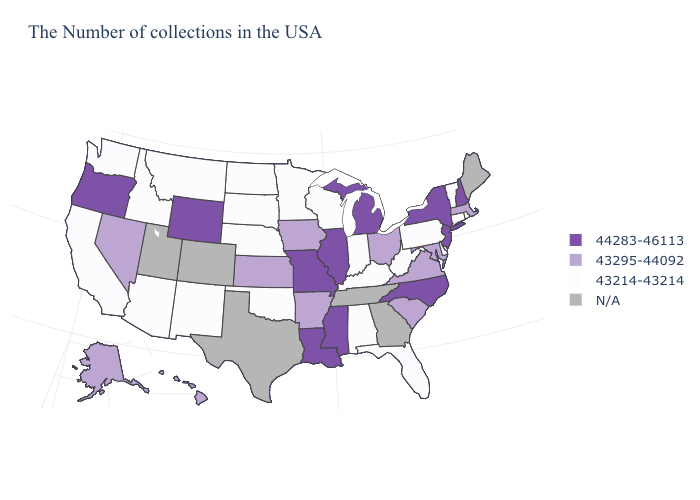What is the value of Washington?
Short answer required. 43214-43214. What is the value of Colorado?
Write a very short answer. N/A. Among the states that border Iowa , does Missouri have the lowest value?
Give a very brief answer. No. What is the value of Idaho?
Answer briefly. 43214-43214. Among the states that border Arkansas , does Oklahoma have the lowest value?
Be succinct. Yes. What is the lowest value in the Northeast?
Short answer required. 43214-43214. Which states have the lowest value in the USA?
Keep it brief. Rhode Island, Vermont, Connecticut, Delaware, Pennsylvania, West Virginia, Florida, Kentucky, Indiana, Alabama, Wisconsin, Minnesota, Nebraska, Oklahoma, South Dakota, North Dakota, New Mexico, Montana, Arizona, Idaho, California, Washington. Name the states that have a value in the range 43214-43214?
Short answer required. Rhode Island, Vermont, Connecticut, Delaware, Pennsylvania, West Virginia, Florida, Kentucky, Indiana, Alabama, Wisconsin, Minnesota, Nebraska, Oklahoma, South Dakota, North Dakota, New Mexico, Montana, Arizona, Idaho, California, Washington. What is the value of Wisconsin?
Be succinct. 43214-43214. What is the value of Virginia?
Keep it brief. 43295-44092. Which states have the lowest value in the USA?
Concise answer only. Rhode Island, Vermont, Connecticut, Delaware, Pennsylvania, West Virginia, Florida, Kentucky, Indiana, Alabama, Wisconsin, Minnesota, Nebraska, Oklahoma, South Dakota, North Dakota, New Mexico, Montana, Arizona, Idaho, California, Washington. Name the states that have a value in the range 43214-43214?
Give a very brief answer. Rhode Island, Vermont, Connecticut, Delaware, Pennsylvania, West Virginia, Florida, Kentucky, Indiana, Alabama, Wisconsin, Minnesota, Nebraska, Oklahoma, South Dakota, North Dakota, New Mexico, Montana, Arizona, Idaho, California, Washington. Name the states that have a value in the range 44283-46113?
Quick response, please. New Hampshire, New York, New Jersey, North Carolina, Michigan, Illinois, Mississippi, Louisiana, Missouri, Wyoming, Oregon. What is the lowest value in the USA?
Short answer required. 43214-43214. 